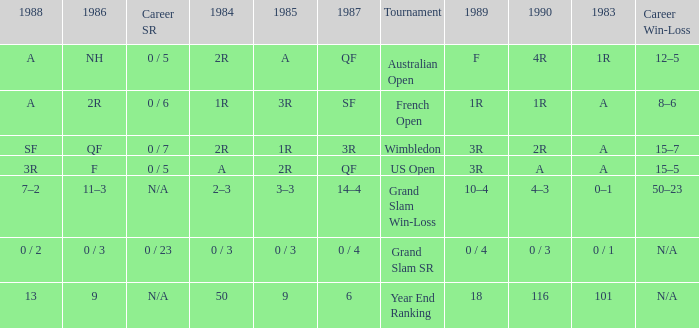What tournament has 0 / 5 as career SR and A as 1983? US Open. 